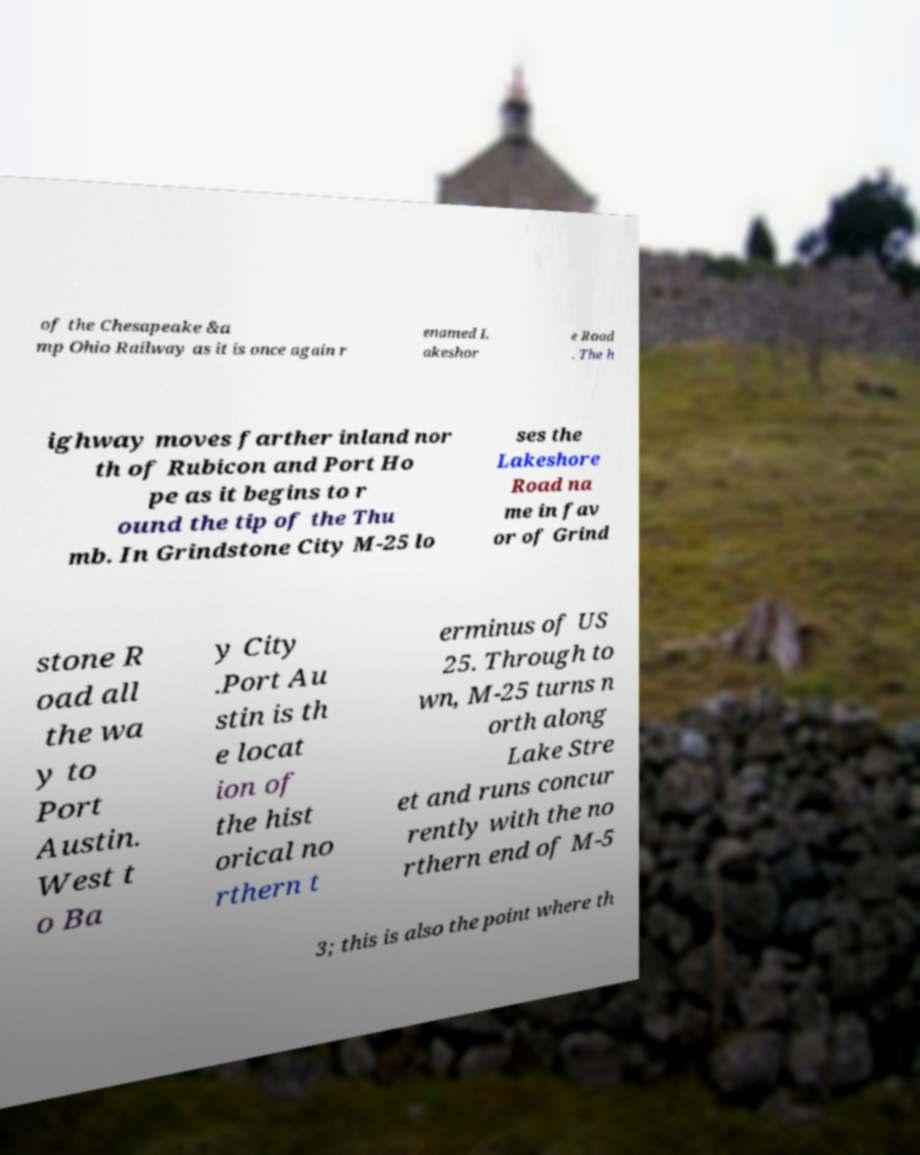What messages or text are displayed in this image? I need them in a readable, typed format. of the Chesapeake &a mp Ohio Railway as it is once again r enamed L akeshor e Road . The h ighway moves farther inland nor th of Rubicon and Port Ho pe as it begins to r ound the tip of the Thu mb. In Grindstone City M-25 lo ses the Lakeshore Road na me in fav or of Grind stone R oad all the wa y to Port Austin. West t o Ba y City .Port Au stin is th e locat ion of the hist orical no rthern t erminus of US 25. Through to wn, M-25 turns n orth along Lake Stre et and runs concur rently with the no rthern end of M-5 3; this is also the point where th 